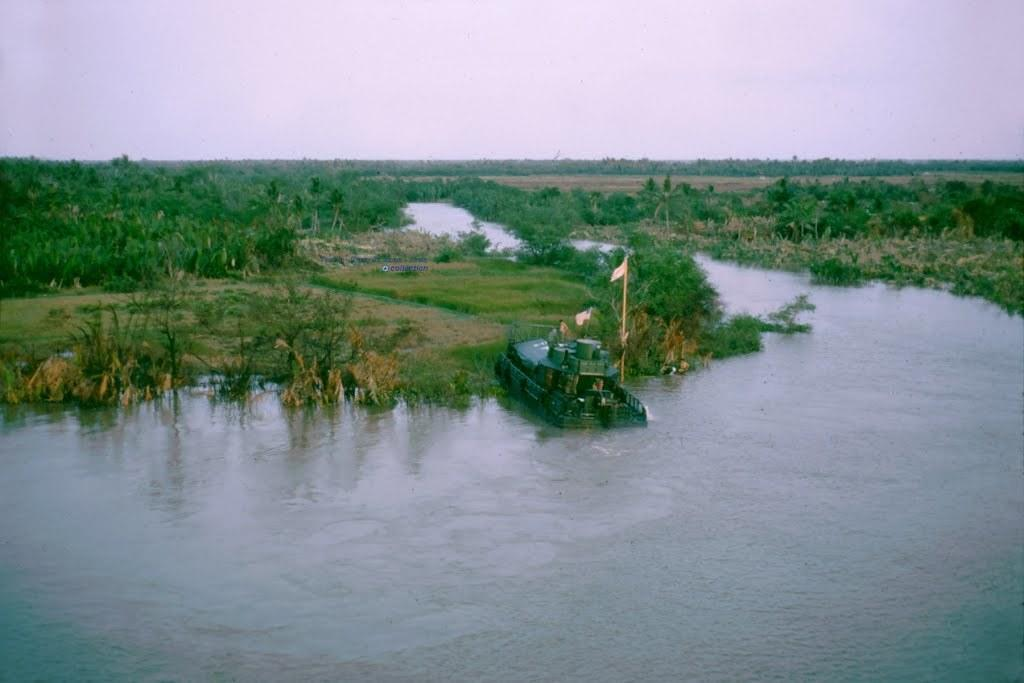What is floating on the surface of the water in the image? There is a boat on the surface of the water in the image. What type of vegetation can be seen in the image? There is grass visible in the image, and there are also trees present. What is visible at the top of the image? The sky is visible at the top of the image. What can be seen flying or attached to the boat in the image? There is a flag in the image. How many pets are visible in the image? There are no pets present in the image. What type of work is being done on the boat in the image? There is no indication of any work being done on the boat in the image. 